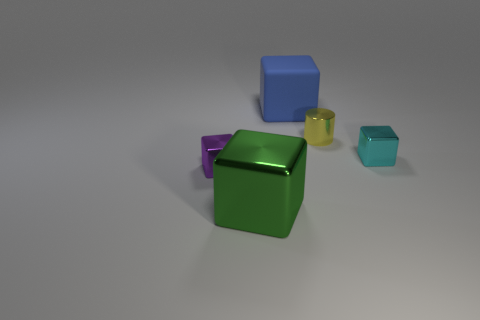Is the material of the yellow cylinder the same as the small thing to the left of the big blue object?
Your answer should be very brief. Yes. There is a thing that is behind the small cyan metal cube and in front of the blue matte thing; what is its shape?
Your answer should be compact. Cylinder. How many other things are there of the same color as the cylinder?
Your answer should be compact. 0. What is the shape of the cyan metal object?
Provide a short and direct response. Cube. What is the color of the small cube in front of the small metallic block that is on the right side of the large metal block?
Your response must be concise. Purple. Does the matte block have the same color as the small thing in front of the small cyan thing?
Give a very brief answer. No. What is the material of the object that is both to the right of the tiny purple metallic block and on the left side of the blue thing?
Your answer should be very brief. Metal. Is there a blue cube of the same size as the yellow metal cylinder?
Your answer should be very brief. No. What material is the purple thing that is the same size as the cyan shiny block?
Provide a short and direct response. Metal. There is a large blue matte cube; how many tiny cylinders are to the right of it?
Ensure brevity in your answer.  1. 